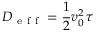Convert formula to latex. <formula><loc_0><loc_0><loc_500><loc_500>D _ { e f f } = \frac { 1 } { 2 } v _ { 0 } ^ { 2 } \tau</formula> 